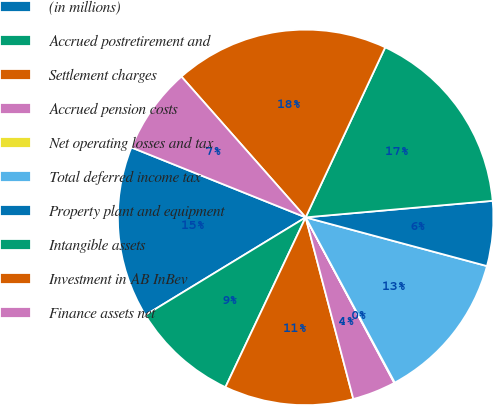<chart> <loc_0><loc_0><loc_500><loc_500><pie_chart><fcel>(in millions)<fcel>Accrued postretirement and<fcel>Settlement charges<fcel>Accrued pension costs<fcel>Net operating losses and tax<fcel>Total deferred income tax<fcel>Property plant and equipment<fcel>Intangible assets<fcel>Investment in AB InBev<fcel>Finance assets net<nl><fcel>14.79%<fcel>9.26%<fcel>11.11%<fcel>3.74%<fcel>0.05%<fcel>12.95%<fcel>5.58%<fcel>16.63%<fcel>18.47%<fcel>7.42%<nl></chart> 